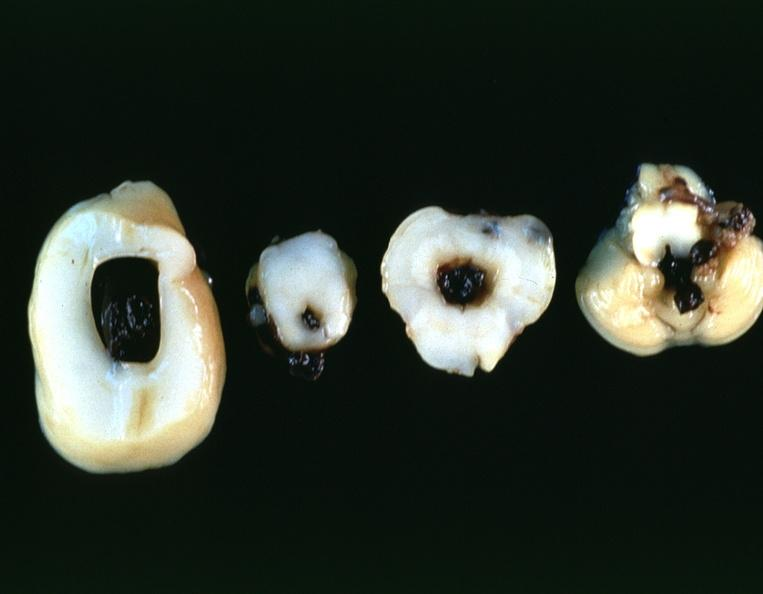s nervous present?
Answer the question using a single word or phrase. Yes 